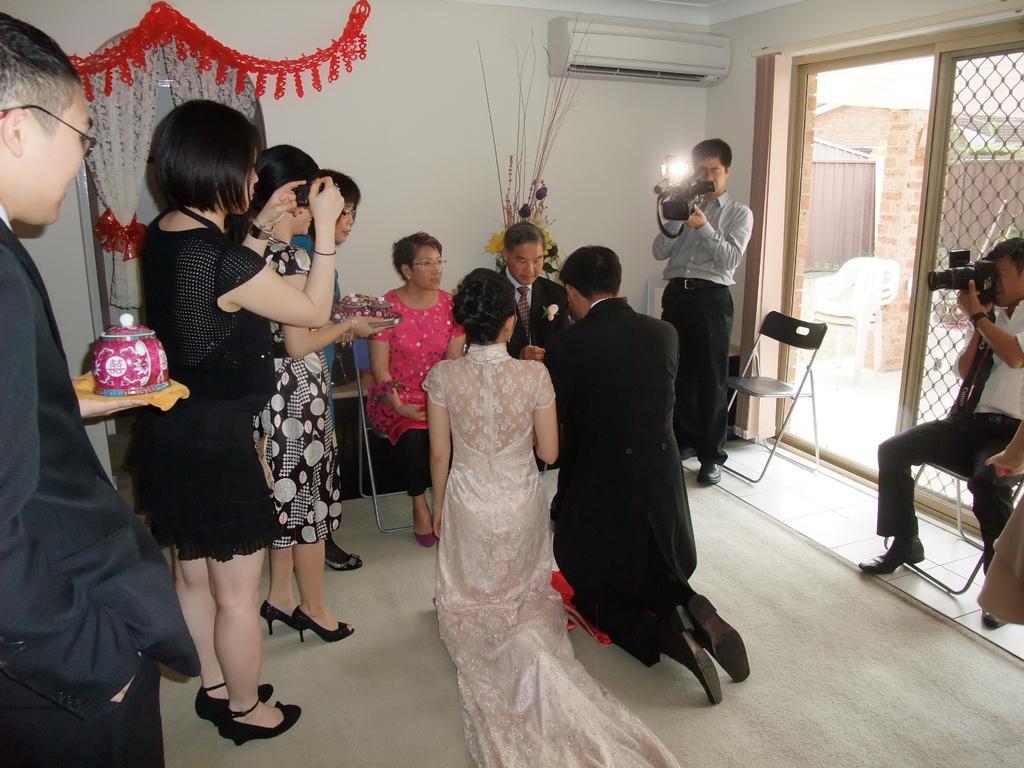Can you describe this image briefly? In this picture we can see a group of people on the floor and three people are sitting on chairs and few people are holding cameras and in the background we can see the wall, curtains, chairs, air conditioner and few objects. 